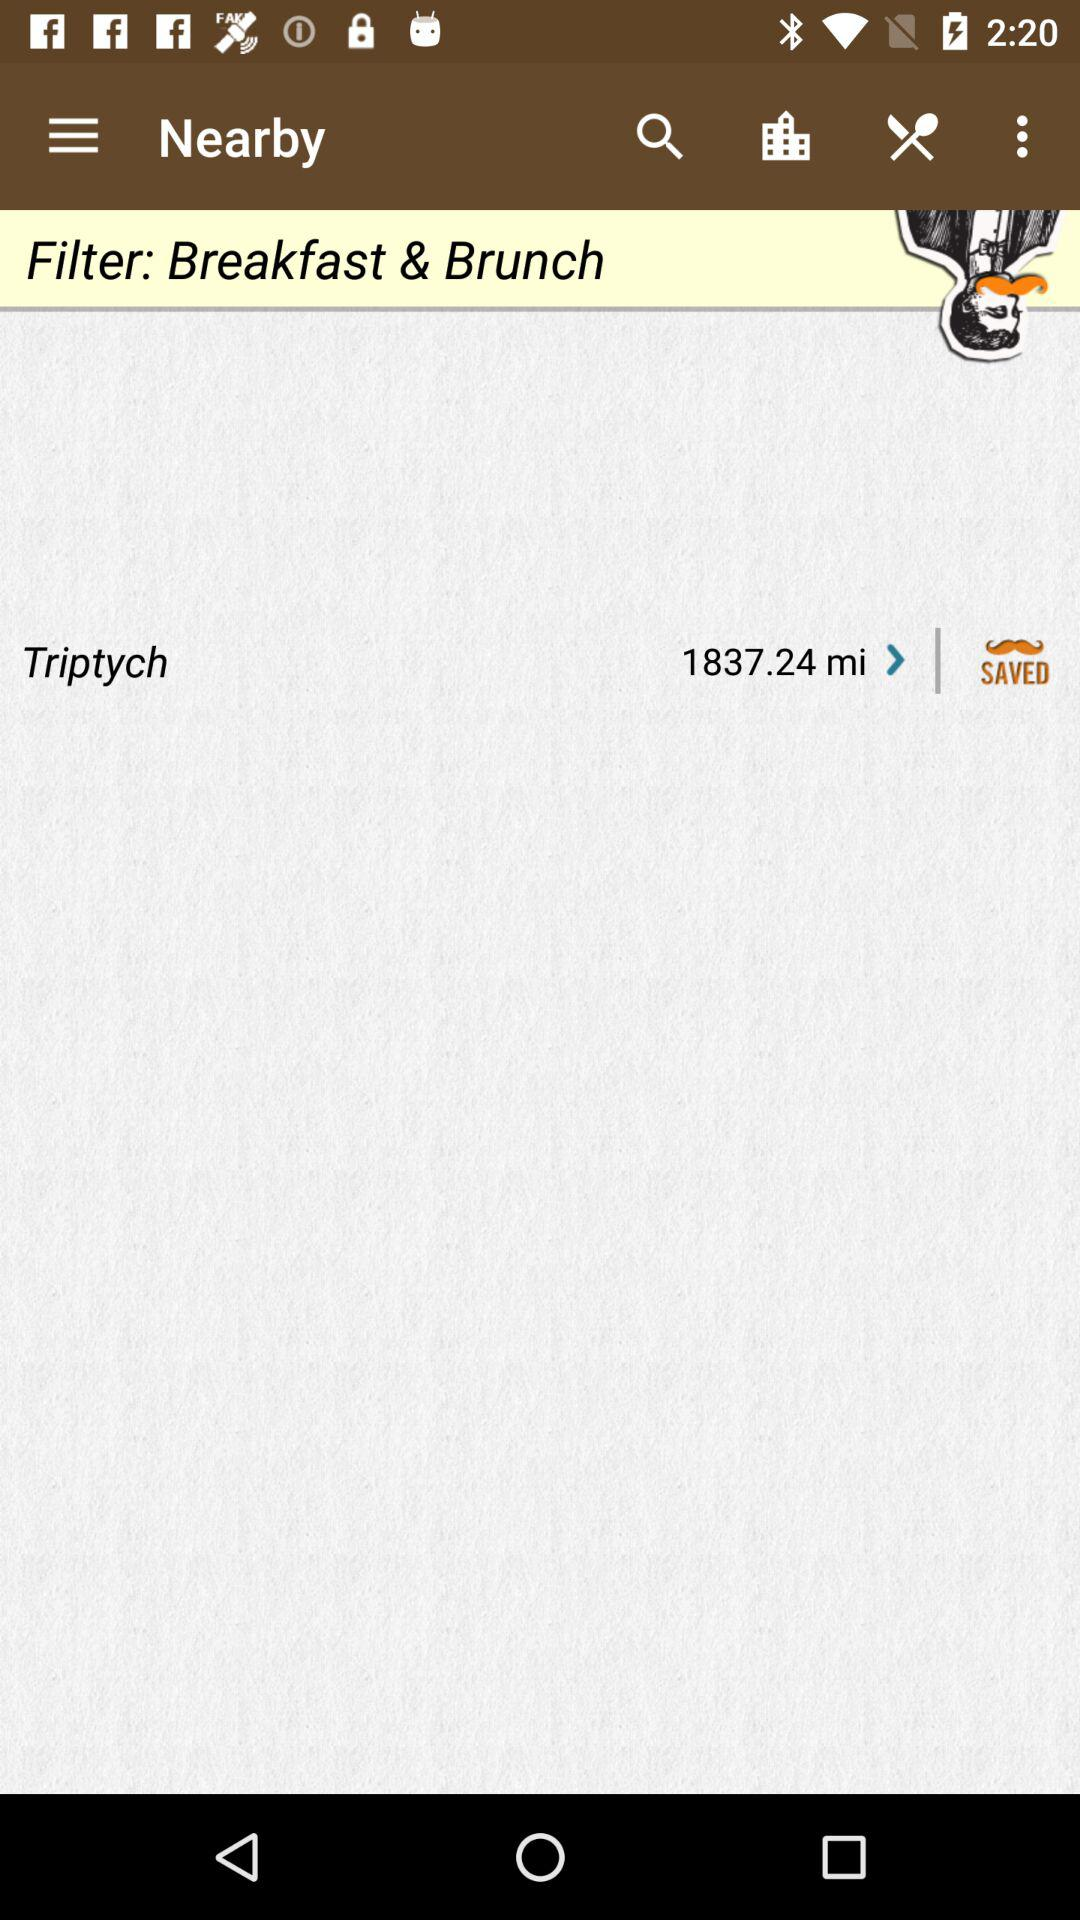How many miles is the restaurant from the user's location?
Answer the question using a single word or phrase. 1837.24 